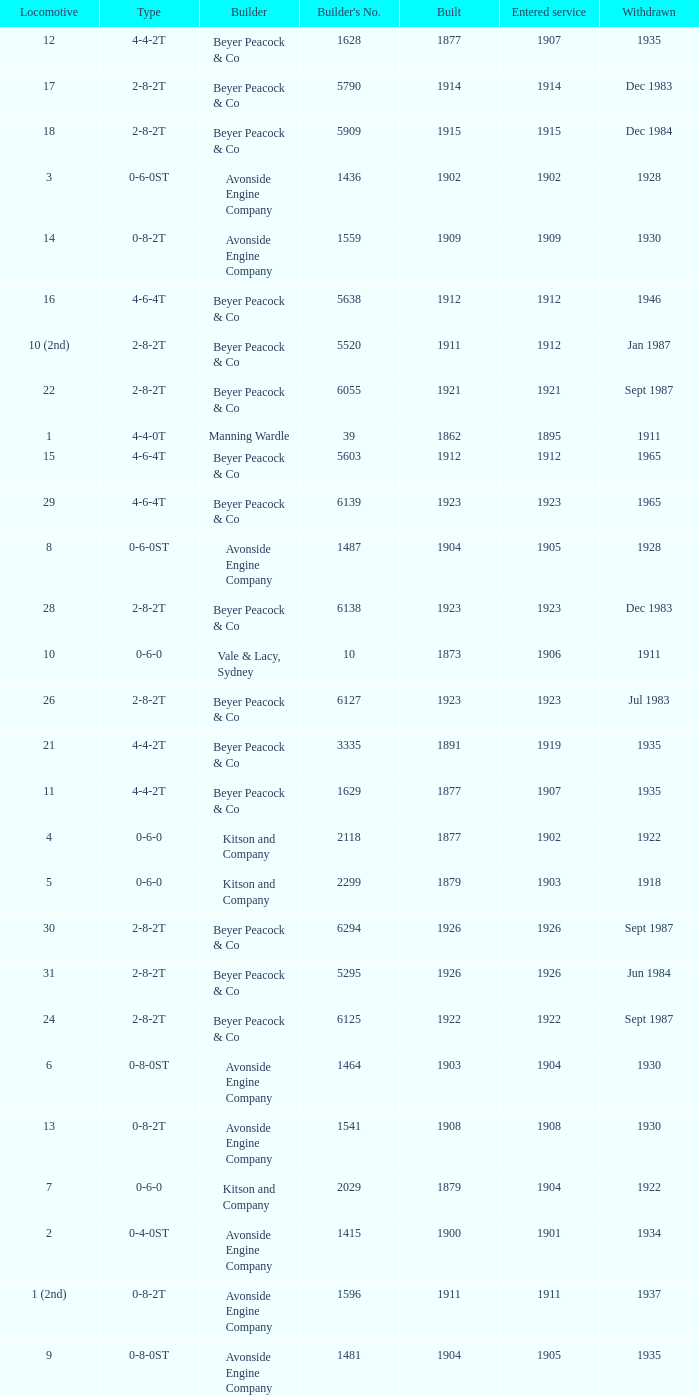How many years entered service when there were 13 locomotives? 1.0. 